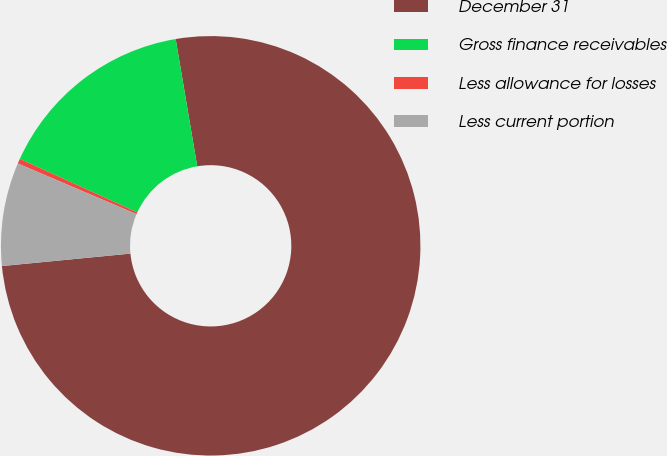<chart> <loc_0><loc_0><loc_500><loc_500><pie_chart><fcel>December 31<fcel>Gross finance receivables<fcel>Less allowance for losses<fcel>Less current portion<nl><fcel>76.13%<fcel>15.53%<fcel>0.38%<fcel>7.96%<nl></chart> 